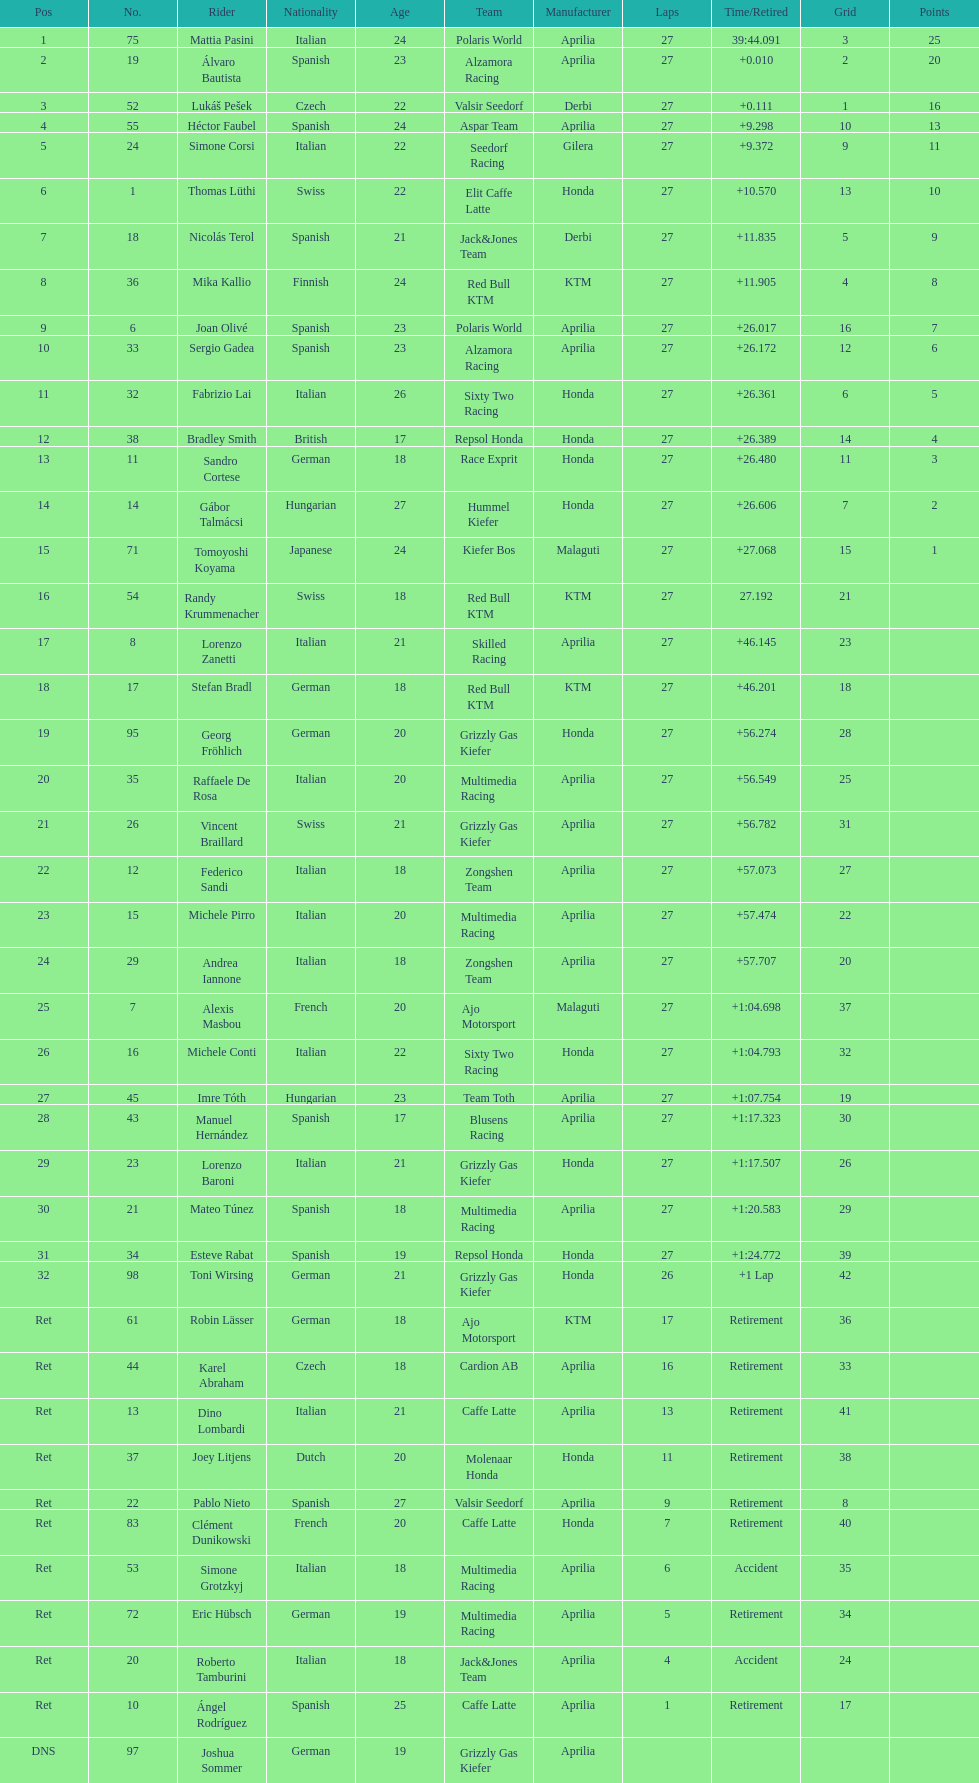What was the total number of positions in the 125cc classification? 43. 